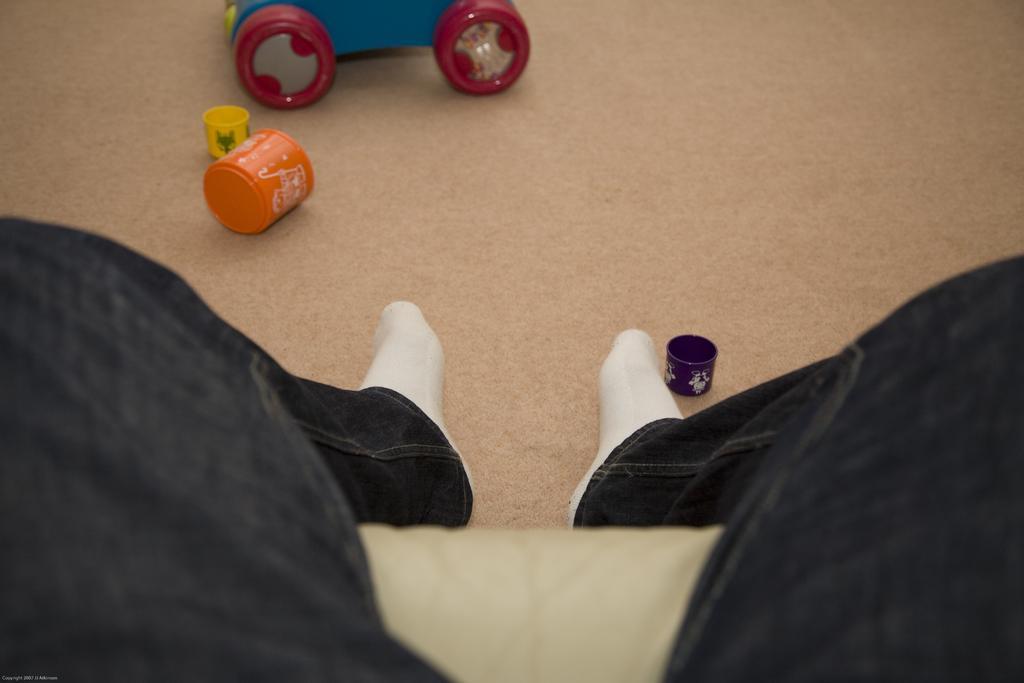Can you describe this image briefly? In this picture, we see the person in black pant who is wearing the white socks is sitting on the sofa or the chair. Beside him, we see a purple color cup and we even see the cups in orange and yellow color. At the top, we see the toy vehicle in blue and red color. 